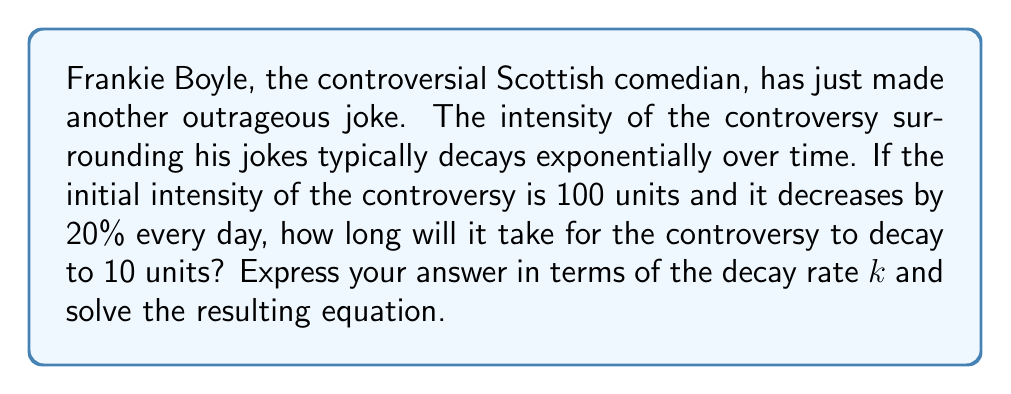Could you help me with this problem? To solve this problem, we need to use the exponential decay model:

$$A(t) = A_0 e^{-kt}$$

Where:
$A(t)$ is the amount at time $t$
$A_0$ is the initial amount
$k$ is the decay rate
$t$ is time

Given:
- Initial intensity $A_0 = 100$ units
- Final intensity $A(t) = 10$ units
- Decay of 20% per day

Step 1: Calculate the decay rate $k$
The decay rate $k$ can be found using the formula:
$$k = -\ln(1-r)$$
Where $r$ is the daily decay rate (0.20 in this case)

$$k = -\ln(1-0.20) = -\ln(0.80) \approx 0.2231$$

Step 2: Set up the exponential decay equation
$$10 = 100e^{-0.2231t}$$

Step 3: Solve for $t$
Divide both sides by 100:
$$0.1 = e^{-0.2231t}$$

Take the natural log of both sides:
$$\ln(0.1) = -0.2231t$$

Solve for $t$:
$$t = \frac{\ln(0.1)}{-0.2231} \approx 10.36$$

Therefore, it will take approximately 10.36 days for the controversy to decay to 10 units.
Answer: $t = \frac{\ln(0.1)}{-k} \approx 10.36$ days, where $k \approx 0.2231$ 